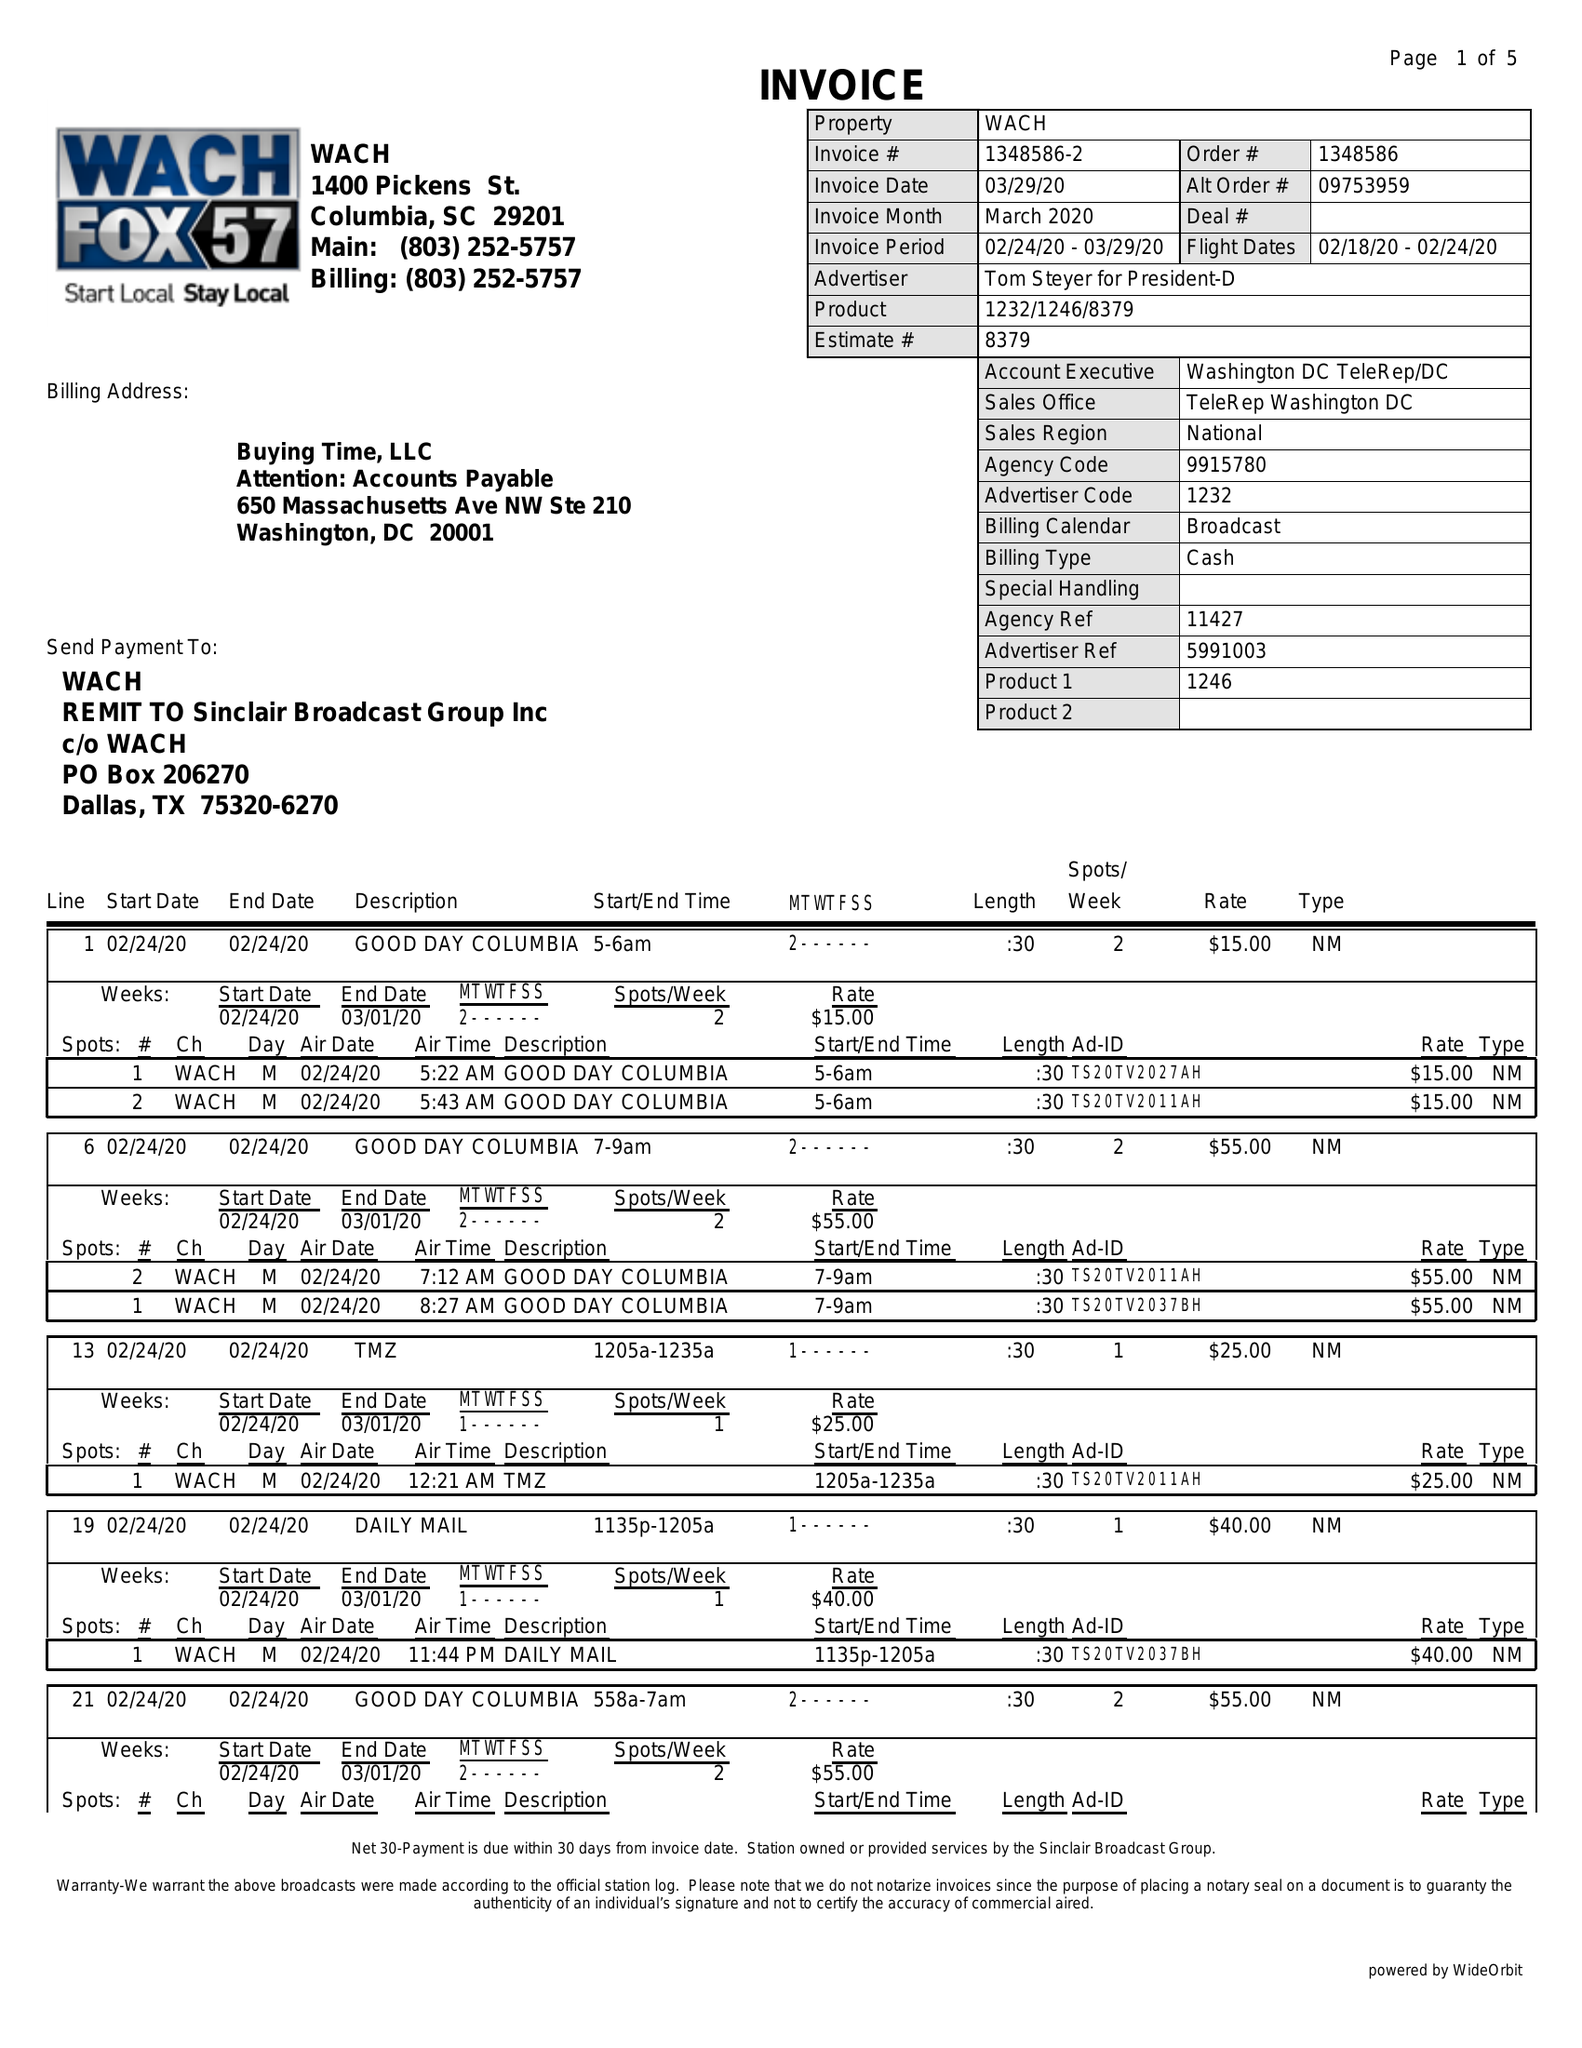What is the value for the flight_from?
Answer the question using a single word or phrase. 02/18/20 